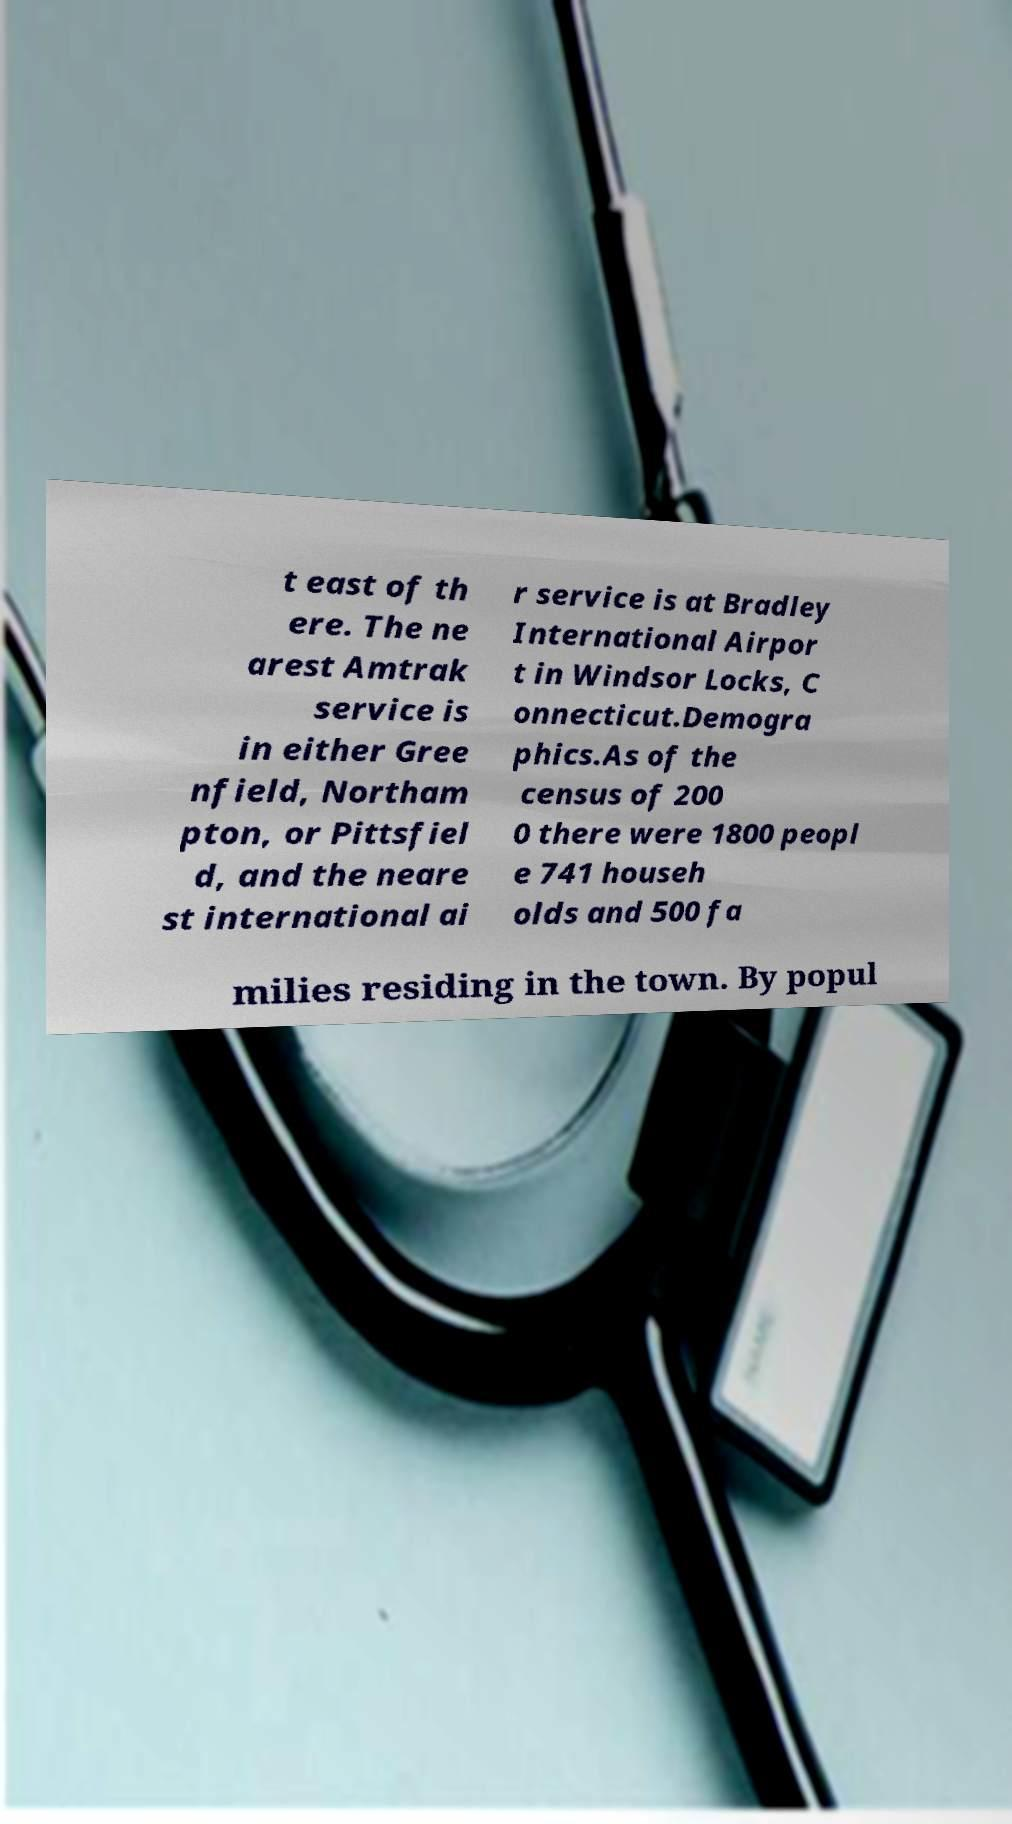Please identify and transcribe the text found in this image. t east of th ere. The ne arest Amtrak service is in either Gree nfield, Northam pton, or Pittsfiel d, and the neare st international ai r service is at Bradley International Airpor t in Windsor Locks, C onnecticut.Demogra phics.As of the census of 200 0 there were 1800 peopl e 741 househ olds and 500 fa milies residing in the town. By popul 